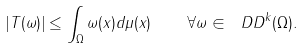<formula> <loc_0><loc_0><loc_500><loc_500>| T ( \omega ) | \leq \int _ { \Omega } \| \omega ( x ) \| d \mu ( x ) \quad \forall \omega \in \ D D ^ { k } ( \Omega ) .</formula> 